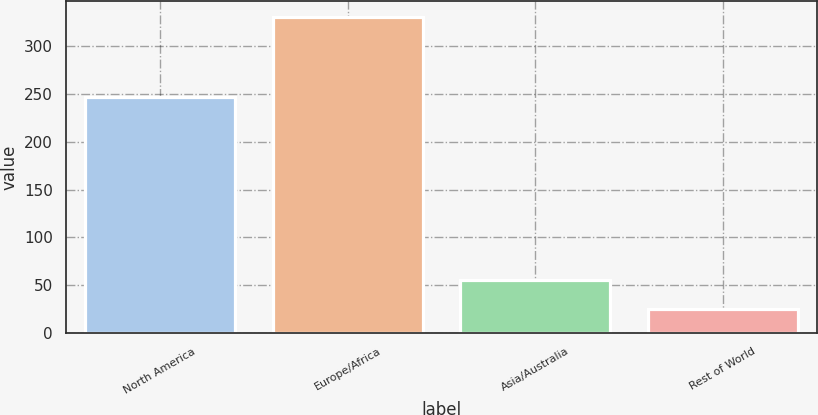Convert chart to OTSL. <chart><loc_0><loc_0><loc_500><loc_500><bar_chart><fcel>North America<fcel>Europe/Africa<fcel>Asia/Australia<fcel>Rest of World<nl><fcel>247<fcel>331<fcel>55.6<fcel>25<nl></chart> 